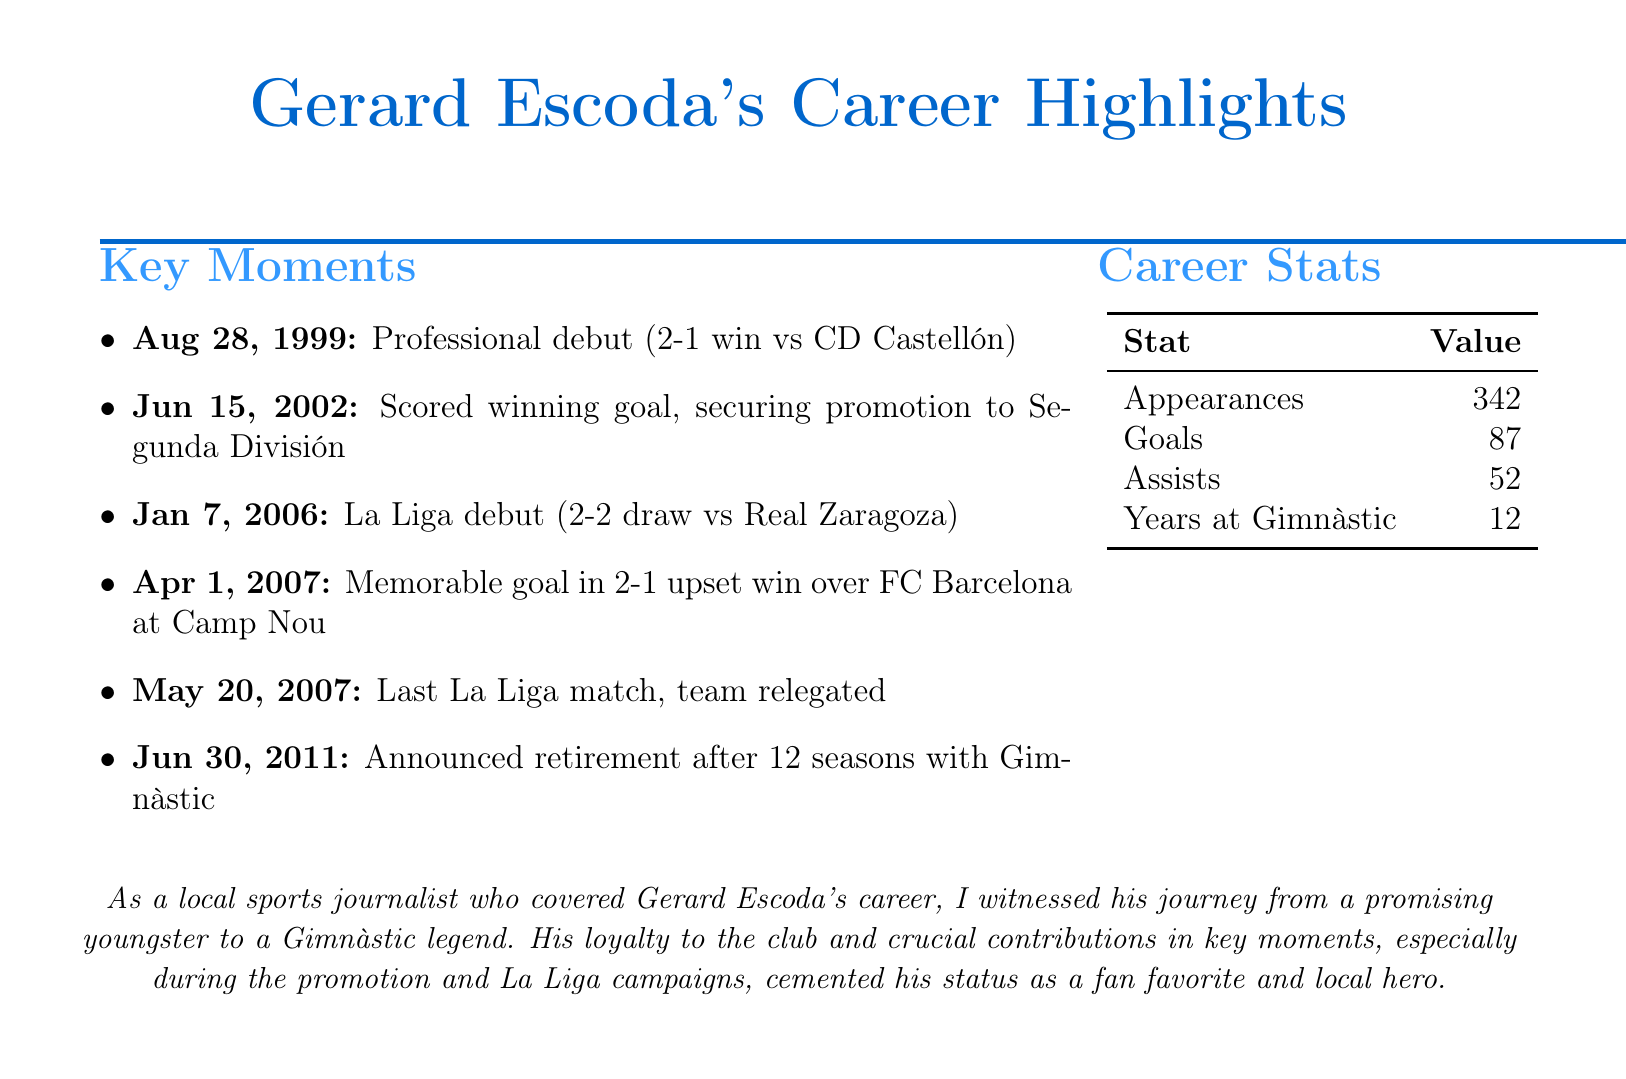What date did Gerard Escoda make his professional debut? The document states that Escoda made his professional debut on August 28, 1999.
Answer: August 28, 1999 What was the score in the match where Escoda scored the winning goal for promotion? According to the document, Escoda scored the winning goal in a 1-0 victory over Racing de Ferrol.
Answer: 1-0 Against which team did Escoda score a crucial goal on April 1, 2007? The document mentions that he scored a memorable goal in an upset win over FC Barcelona.
Answer: FC Barcelona How many total appearances did Escoda make in his career? The document lists the total appearances for Escoda as 342.
Answer: 342 When did Escoda announce his retirement from professional football? The document specifies that he announced his retirement on June 30, 2011.
Answer: June 30, 2011 What significant event took place during Gerard Escoda's La Liga debut? The document highlights that he made his La Liga debut in a 2-2 draw against Real Zaragoza.
Answer: 2-2 draw How many goals did Escoda score in his professional career? The document indicates that he scored a total of 87 goals.
Answer: 87 What is the total number of assists recorded by Escoda? The document states that Escoda made 52 assists during his career.
Answer: 52 Which team did Gimnàstic de Tarragona lose to in their last La Liga match? The document notes that Gimnàstic lost 1-0 to Real Madrid in their last La Liga match.
Answer: Real Madrid 